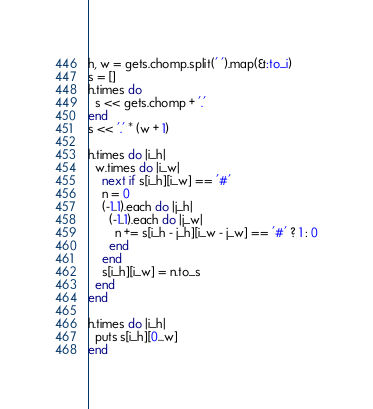<code> <loc_0><loc_0><loc_500><loc_500><_Ruby_>h, w = gets.chomp.split(' ').map(&:to_i)
s = []
h.times do
  s << gets.chomp + '.'
end
s << '.' * (w + 1)

h.times do |i_h|
  w.times do |i_w|
    next if s[i_h][i_w] == '#'
    n = 0
    (-1..1).each do |j_h|
      (-1..1).each do |j_w|
        n += s[i_h - j_h][i_w - j_w] == '#' ? 1 : 0
      end
    end
    s[i_h][i_w] = n.to_s
  end
end

h.times do |i_h|
  puts s[i_h][0...w]
end
</code> 